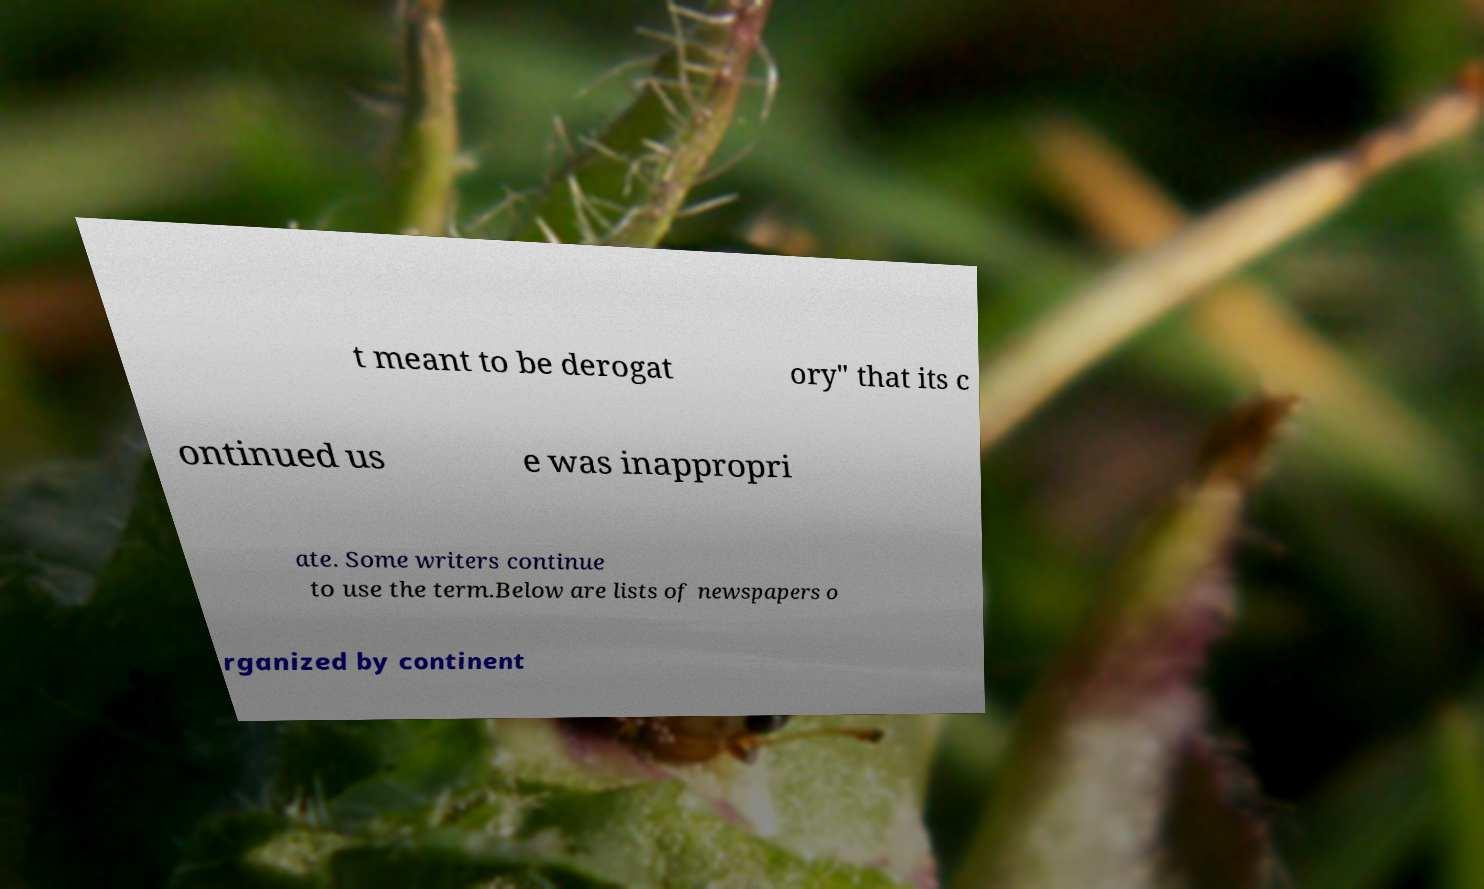Could you extract and type out the text from this image? t meant to be derogat ory" that its c ontinued us e was inappropri ate. Some writers continue to use the term.Below are lists of newspapers o rganized by continent 